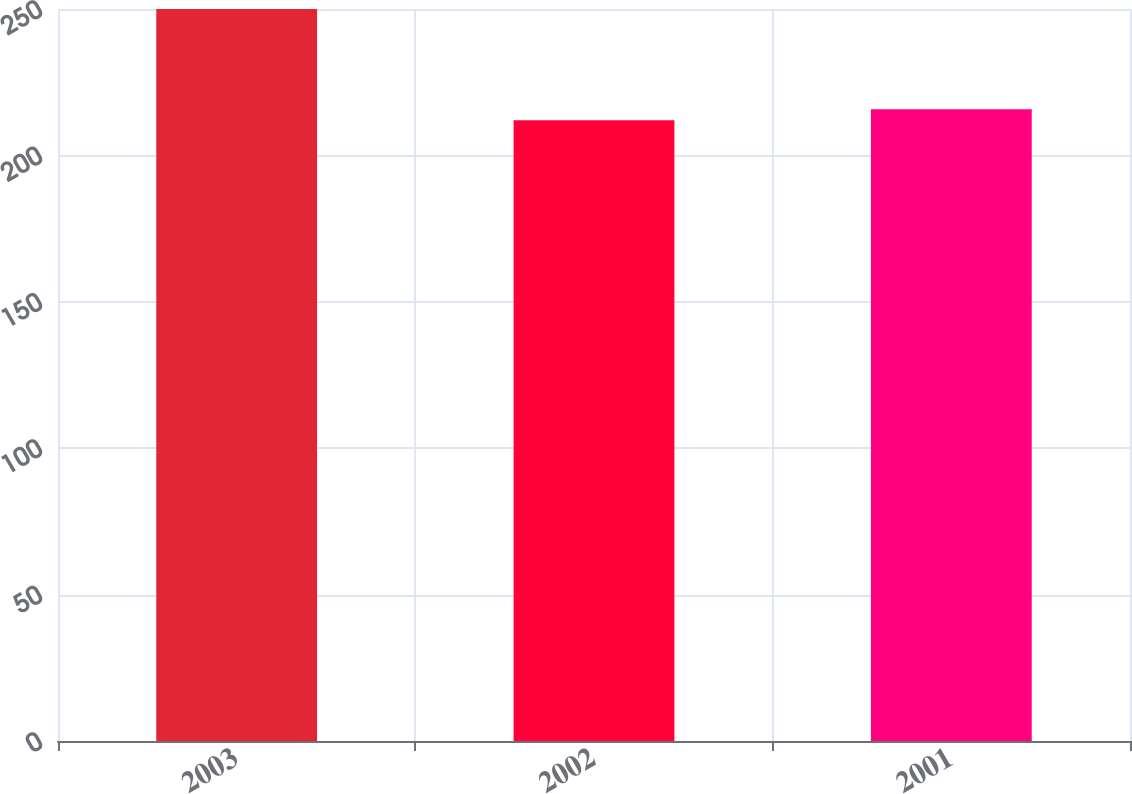Convert chart to OTSL. <chart><loc_0><loc_0><loc_500><loc_500><bar_chart><fcel>2003<fcel>2002<fcel>2001<nl><fcel>250<fcel>212<fcel>215.8<nl></chart> 